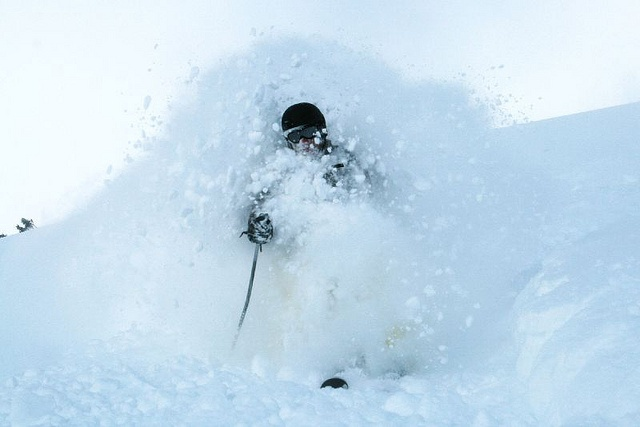Describe the objects in this image and their specific colors. I can see people in white, lightblue, black, and gray tones in this image. 